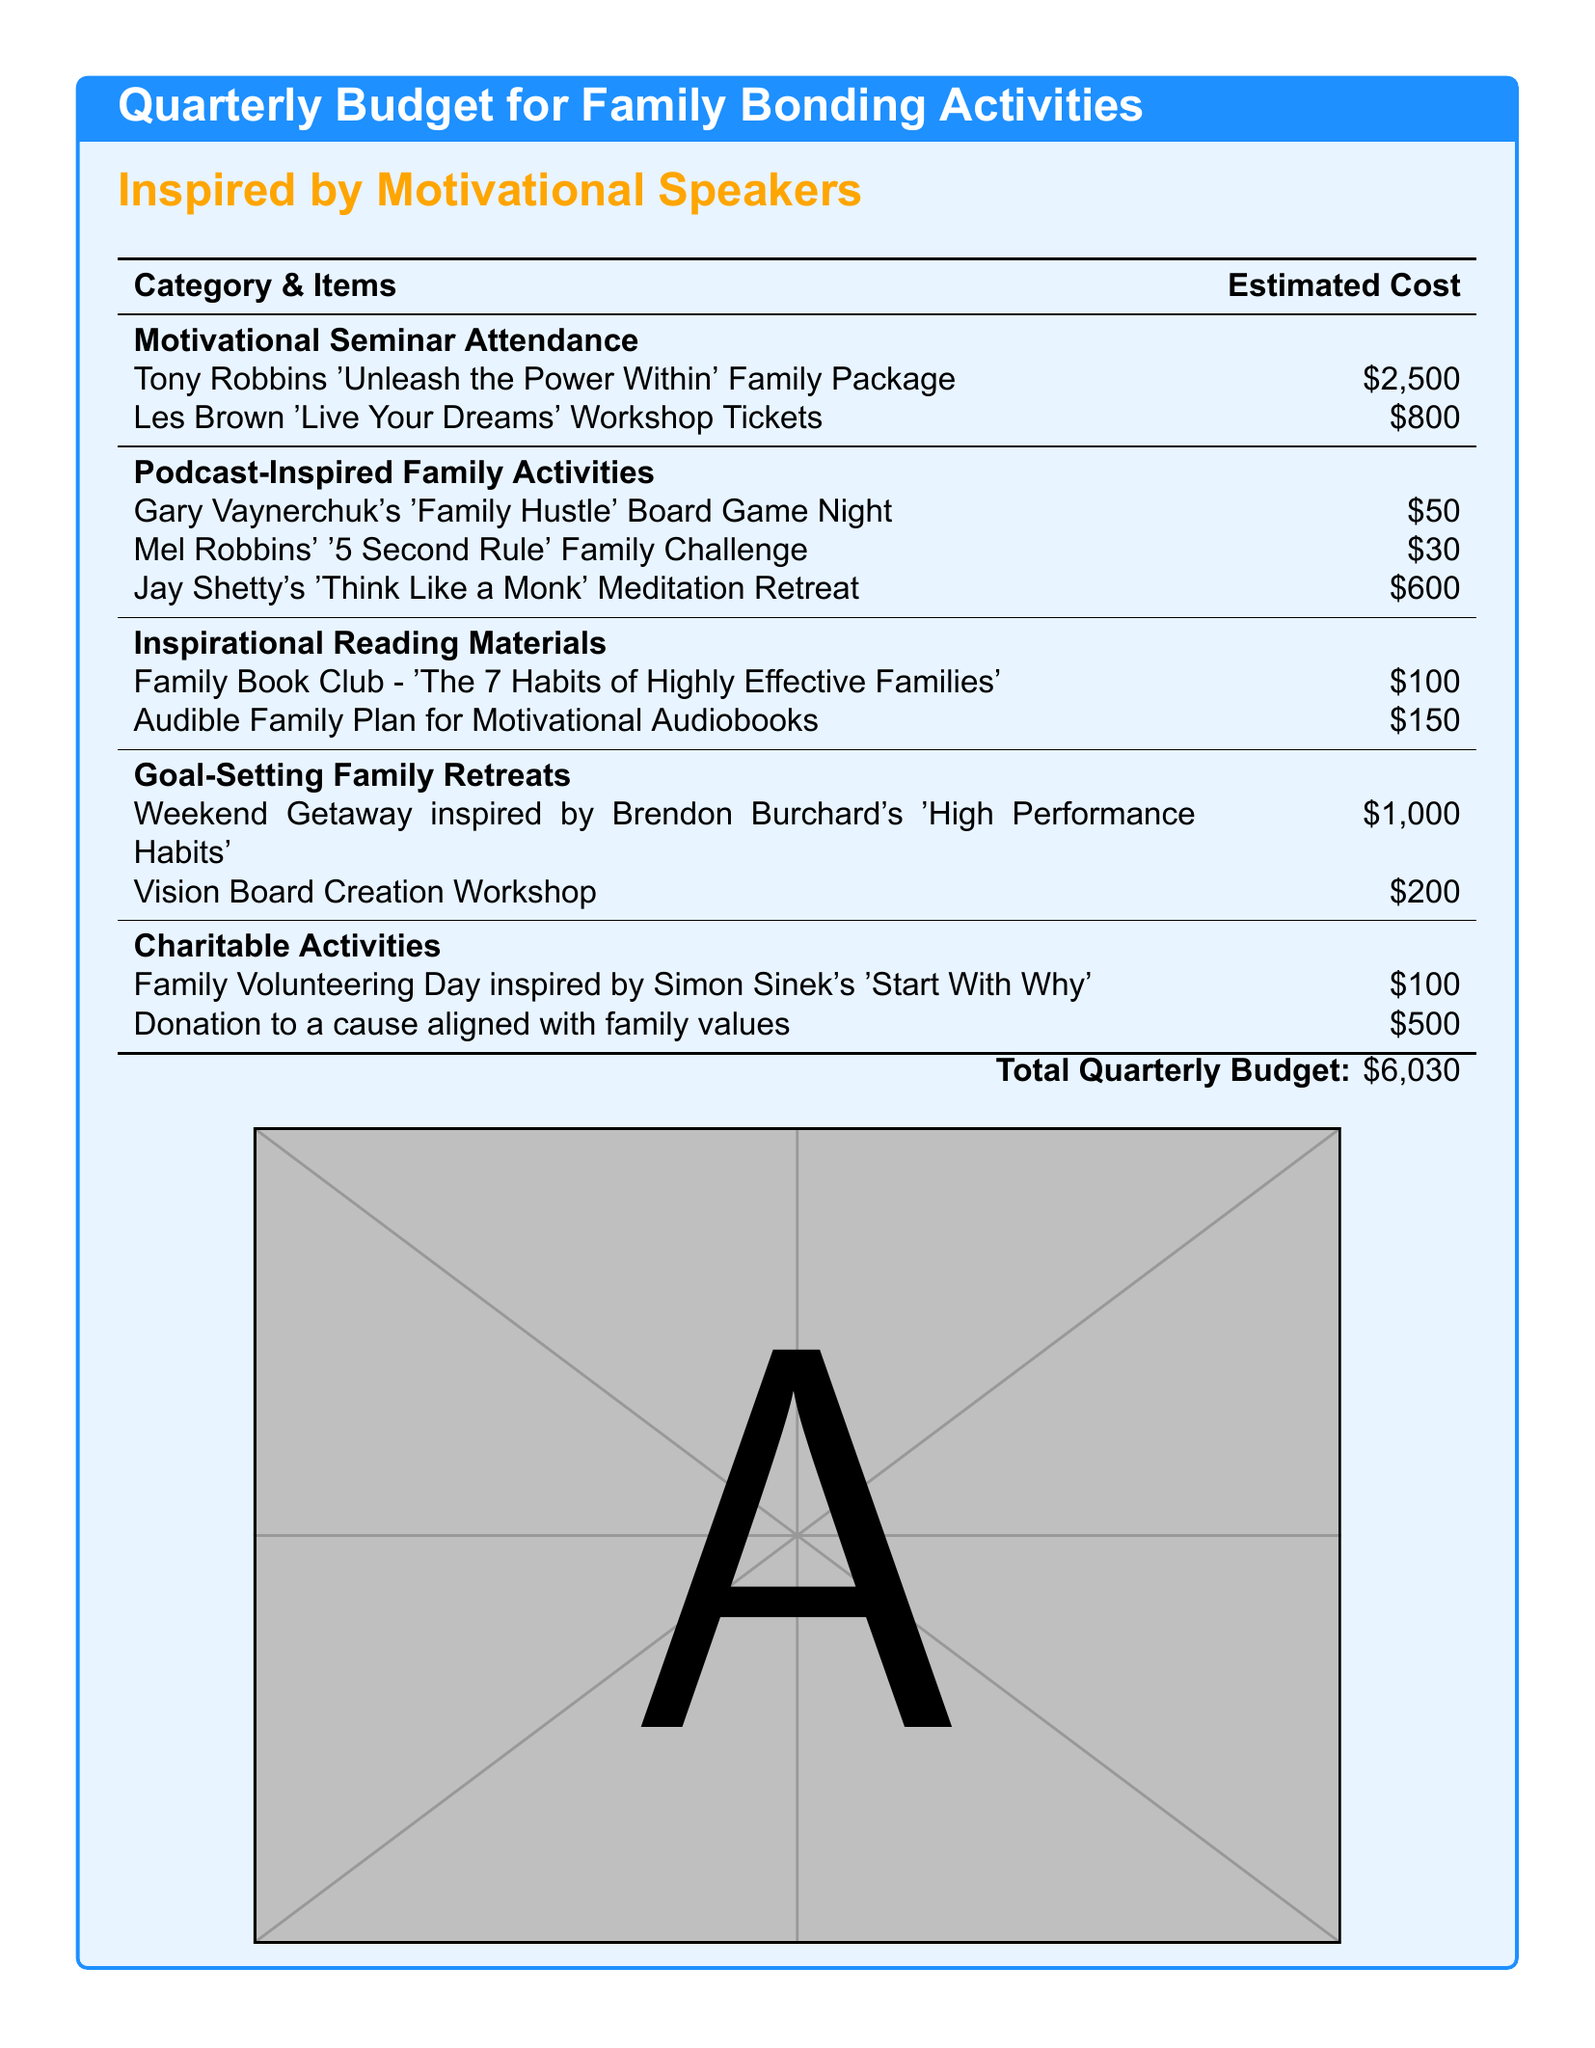What is the total estimated cost for the quarterly budget? The total estimated cost is presented at the bottom of the document, summarizing all expenses listed above.
Answer: $6,030 How much does the family package for Tony Robbins' seminar cost? The specific cost for the Tony Robbins 'Unleash the Power Within' Family Package is detailed in the motivational seminar section of the budget.
Answer: $2,500 What is the cost of the '5 Second Rule' Family Challenge? The price for Mel Robbins' inspired activity can be found in the podcast-inspired family activities section.
Answer: $30 Which motivational speaker is associated with the vision board creation workshop? This workshop is included in the goal-setting family retreats, implying a motivational influence but not directly citing a speaker beside it.
Answer: Brendon Burchard's How much is allocated for the 'Family Hustle' Board Game Night? The document specifies the cost for this family activity clearly under the podcast-inspired activities.
Answer: $50 What is the budget for charitable activities? The total costs for charitable activities listed in the document can be derived from the respective item costs.
Answer: $600 How many motivational speakers are mentioned in the budget? By listing the various activities, one can count the distinct motivational speakers mentioned throughout the document.
Answer: 7 What family activity is inspired by Simon Sinek? This question specifically addresses the unethical reasoning, prompting the document's additional insight into charitable activities noted there.
Answer: Family Volunteering Day What type of retreat is suggested in the document? The term 'retreat' signifies the goal-setting concept depicted in the family bonding activities.
Answer: Family Retreat 